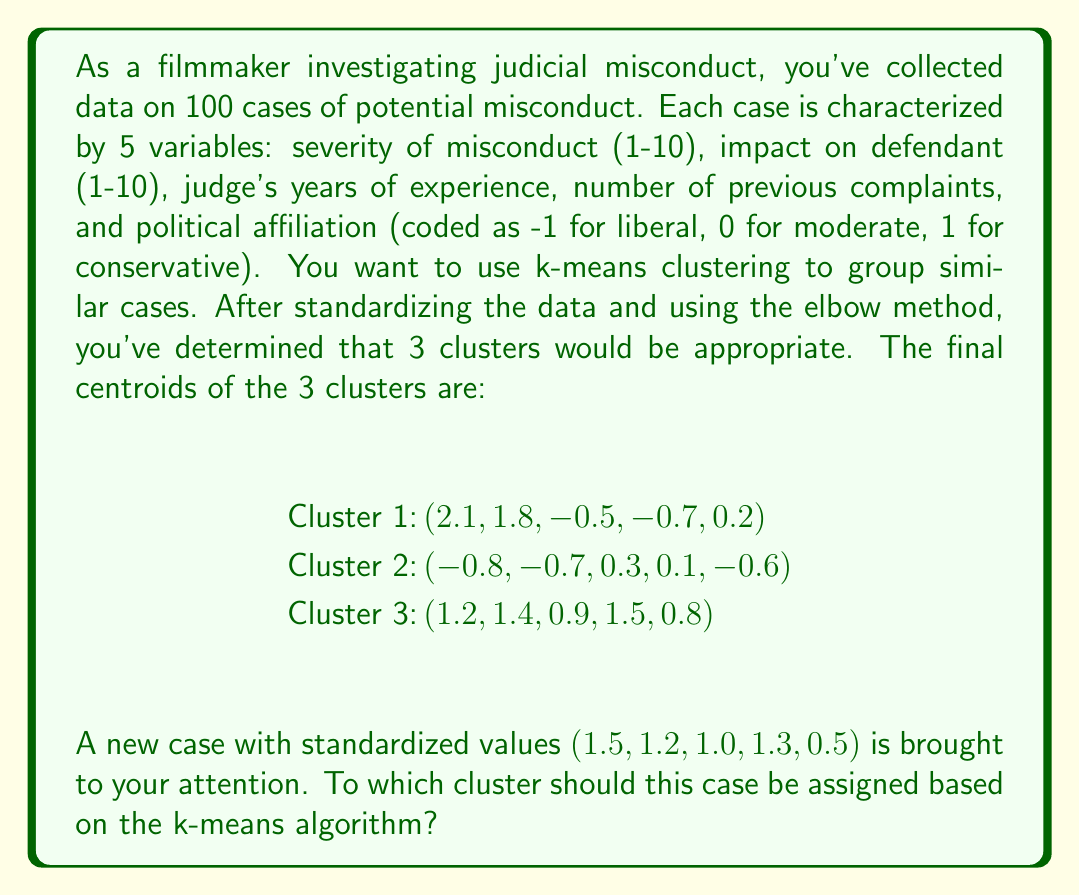Show me your answer to this math problem. To determine which cluster the new case should be assigned to, we need to calculate the Euclidean distance between the new case and each cluster centroid. The case will be assigned to the cluster with the smallest distance.

Let's denote the new case as $x = (1.5, 1.2, 1.0, 1.3, 0.5)$

For each cluster centroid $c_i$, we calculate the Euclidean distance using the formula:

$$ d(x, c_i) = \sqrt{\sum_{j=1}^5 (x_j - c_{ij})^2} $$

Where $x_j$ is the $j$-th component of the new case, and $c_{ij}$ is the $j$-th component of the $i$-th cluster centroid.

For Cluster 1:
$$ \begin{align}
d(x, c_1) &= \sqrt{(1.5-2.1)^2 + (1.2-1.8)^2 + (1.0-(-0.5))^2 + (1.3-(-0.7))^2 + (0.5-0.2)^2} \\
&= \sqrt{(-0.6)^2 + (-0.6)^2 + (1.5)^2 + (2.0)^2 + (0.3)^2} \\
&= \sqrt{0.36 + 0.36 + 2.25 + 4.00 + 0.09} \\
&= \sqrt{7.06} \\
&\approx 2.66
\end{align} $$

For Cluster 2:
$$ \begin{align}
d(x, c_2) &= \sqrt{(1.5-(-0.8))^2 + (1.2-(-0.7))^2 + (1.0-0.3)^2 + (1.3-0.1)^2 + (0.5-(-0.6))^2} \\
&= \sqrt{(2.3)^2 + (1.9)^2 + (0.7)^2 + (1.2)^2 + (1.1)^2} \\
&= \sqrt{5.29 + 3.61 + 0.49 + 1.44 + 1.21} \\
&= \sqrt{12.04} \\
&\approx 3.47
\end{align} $$

For Cluster 3:
$$ \begin{align}
d(x, c_3) &= \sqrt{(1.5-1.2)^2 + (1.2-1.4)^2 + (1.0-0.9)^2 + (1.3-1.5)^2 + (0.5-0.8)^2} \\
&= \sqrt{(0.3)^2 + (-0.2)^2 + (0.1)^2 + (-0.2)^2 + (-0.3)^2} \\
&= \sqrt{0.09 + 0.04 + 0.01 + 0.04 + 0.09} \\
&= \sqrt{0.27} \\
&\approx 0.52
\end{align} $$

The smallest distance is to Cluster 3, so the new case should be assigned to this cluster.
Answer: Cluster 3 